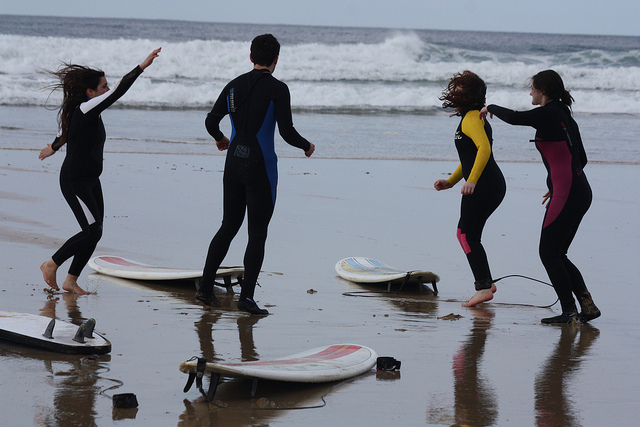What are the people doing in the image? The individuals appear to be standing by their surfboards on the beach, possibly preparing to surf or taking a break from the water. There's a sense of motion as one person is captured mid-gesture, perhaps talking or playing with the others. 